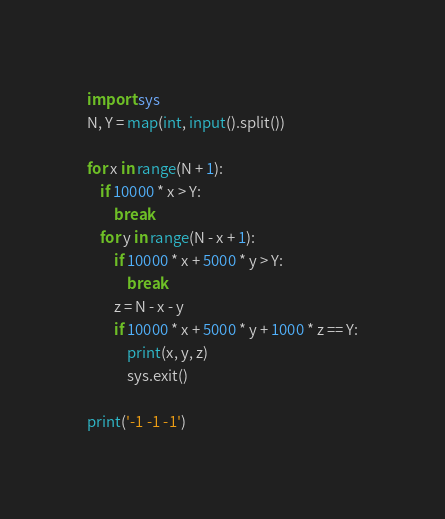<code> <loc_0><loc_0><loc_500><loc_500><_Python_>import sys
N, Y = map(int, input().split())

for x in range(N + 1):
    if 10000 * x > Y:
        break
    for y in range(N - x + 1):
        if 10000 * x + 5000 * y > Y:
            break
        z = N - x - y
        if 10000 * x + 5000 * y + 1000 * z == Y:
            print(x, y, z)
            sys.exit()

print('-1 -1 -1')</code> 